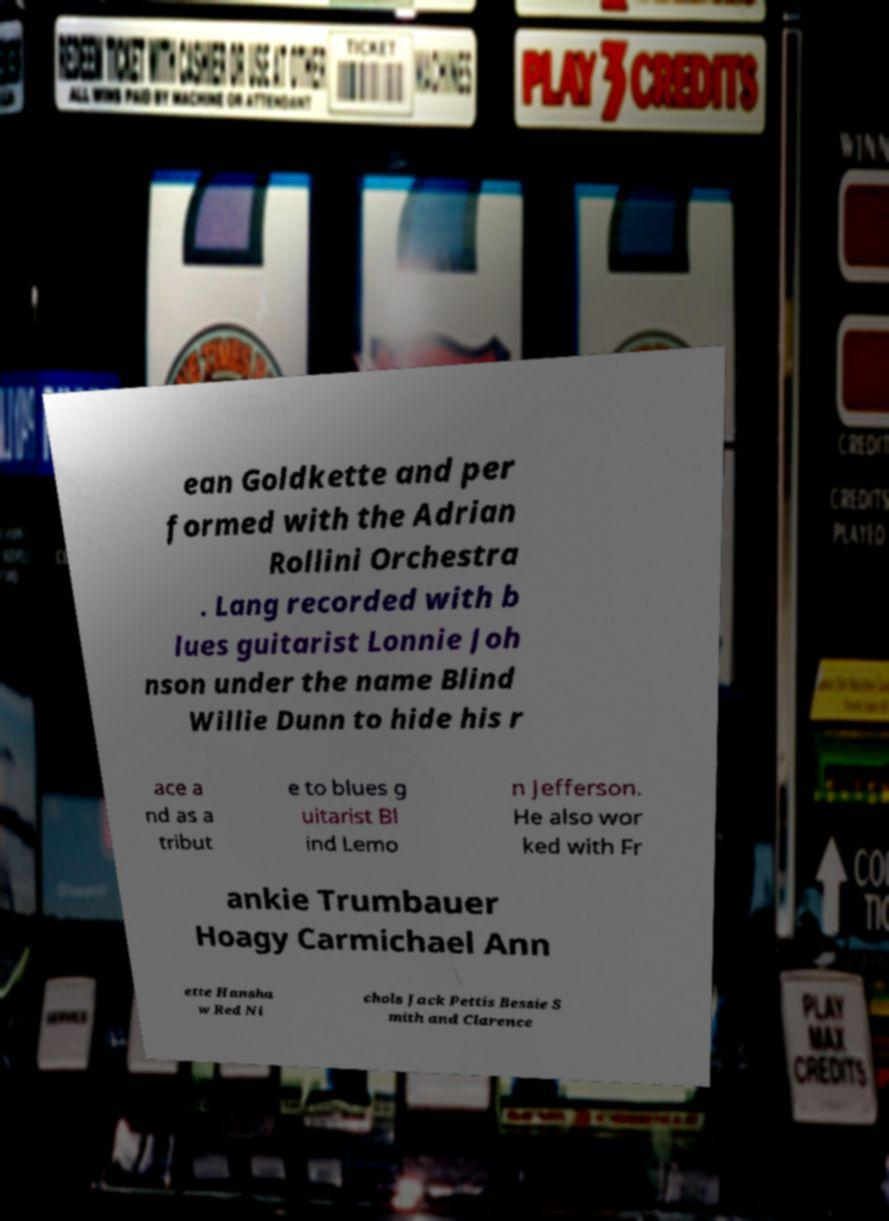What messages or text are displayed in this image? I need them in a readable, typed format. ean Goldkette and per formed with the Adrian Rollini Orchestra . Lang recorded with b lues guitarist Lonnie Joh nson under the name Blind Willie Dunn to hide his r ace a nd as a tribut e to blues g uitarist Bl ind Lemo n Jefferson. He also wor ked with Fr ankie Trumbauer Hoagy Carmichael Ann ette Hansha w Red Ni chols Jack Pettis Bessie S mith and Clarence 